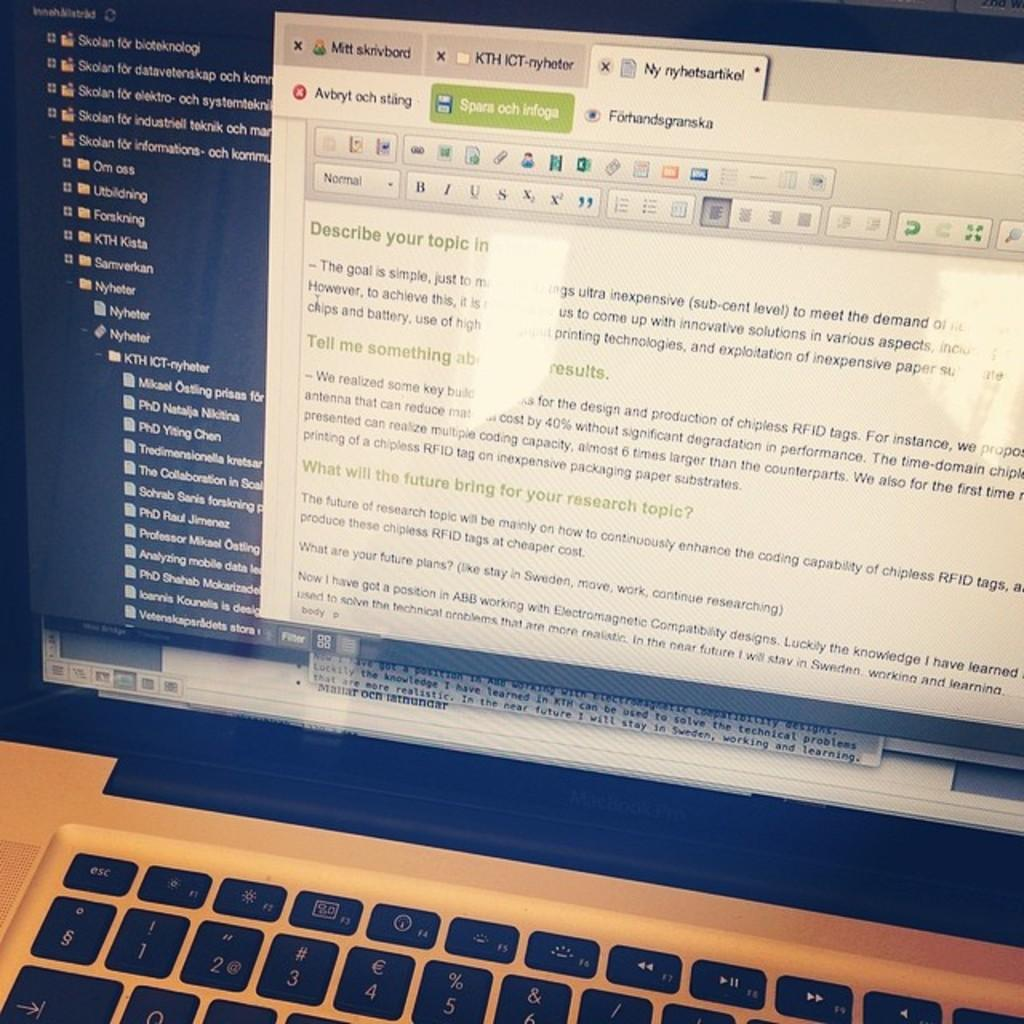<image>
Present a compact description of the photo's key features. A file folder labeled NY nyhotsartikol is open on a computer screen 